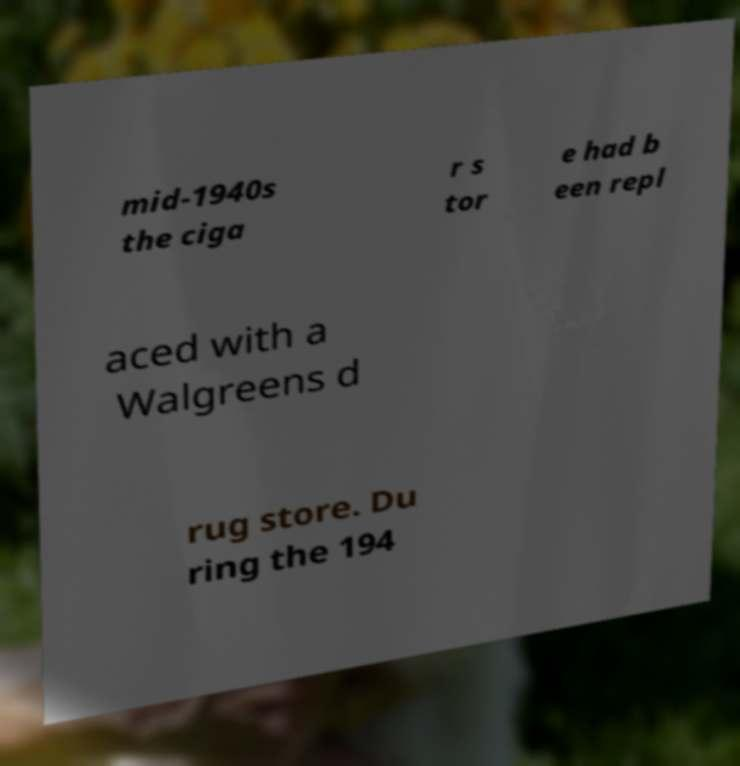Please identify and transcribe the text found in this image. mid-1940s the ciga r s tor e had b een repl aced with a Walgreens d rug store. Du ring the 194 